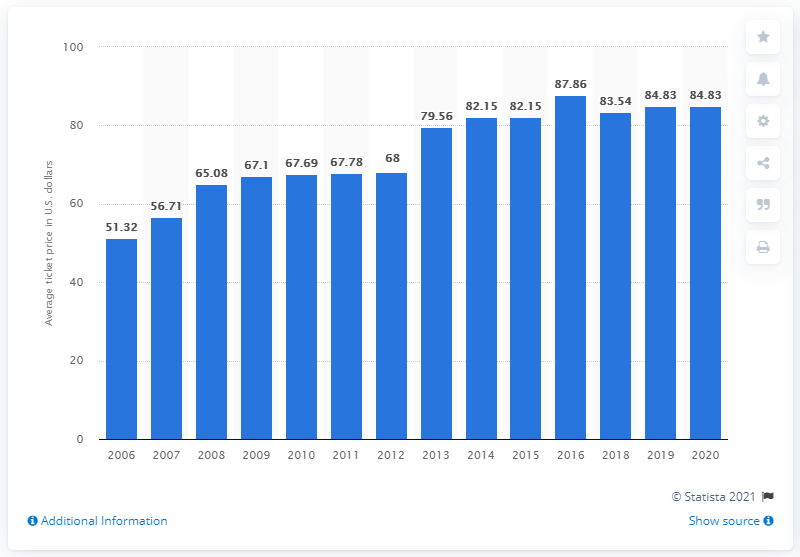Mention a couple of crucial points in this snapshot. The average ticket price for Arizona Cardinals games in 2020 was 84.83 dollars. 